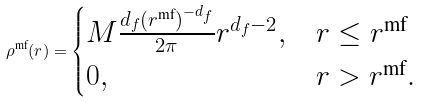<formula> <loc_0><loc_0><loc_500><loc_500>\rho ^ { \text {mf} } ( r ) = \begin{cases} M \frac { d _ { f } ( r ^ { \text {mf} } ) ^ { - d _ { f } } } { 2 \pi } r ^ { d _ { f } - 2 } , & r \leq r ^ { \text {mf} } \\ 0 , & r > r ^ { \text {mf} } . \end{cases}</formula> 